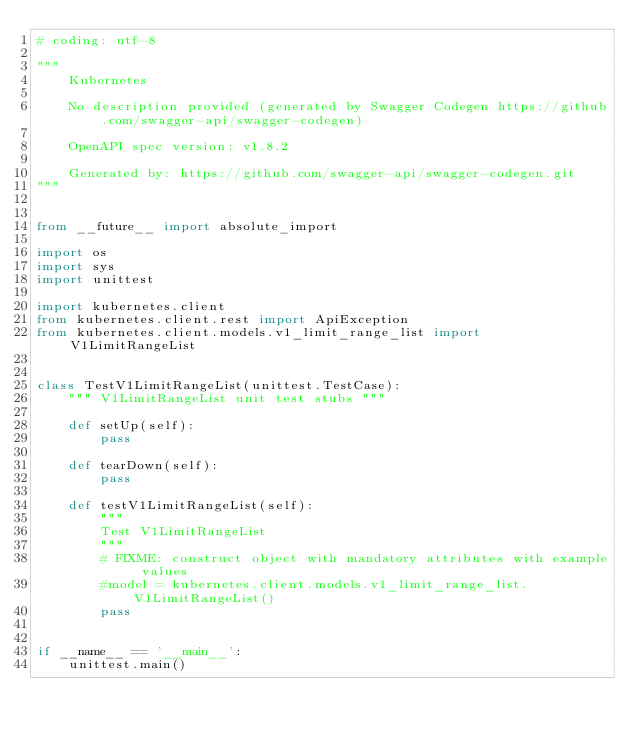Convert code to text. <code><loc_0><loc_0><loc_500><loc_500><_Python_># coding: utf-8

"""
    Kubernetes

    No description provided (generated by Swagger Codegen https://github.com/swagger-api/swagger-codegen)

    OpenAPI spec version: v1.8.2
    
    Generated by: https://github.com/swagger-api/swagger-codegen.git
"""


from __future__ import absolute_import

import os
import sys
import unittest

import kubernetes.client
from kubernetes.client.rest import ApiException
from kubernetes.client.models.v1_limit_range_list import V1LimitRangeList


class TestV1LimitRangeList(unittest.TestCase):
    """ V1LimitRangeList unit test stubs """

    def setUp(self):
        pass

    def tearDown(self):
        pass

    def testV1LimitRangeList(self):
        """
        Test V1LimitRangeList
        """
        # FIXME: construct object with mandatory attributes with example values
        #model = kubernetes.client.models.v1_limit_range_list.V1LimitRangeList()
        pass


if __name__ == '__main__':
    unittest.main()
</code> 